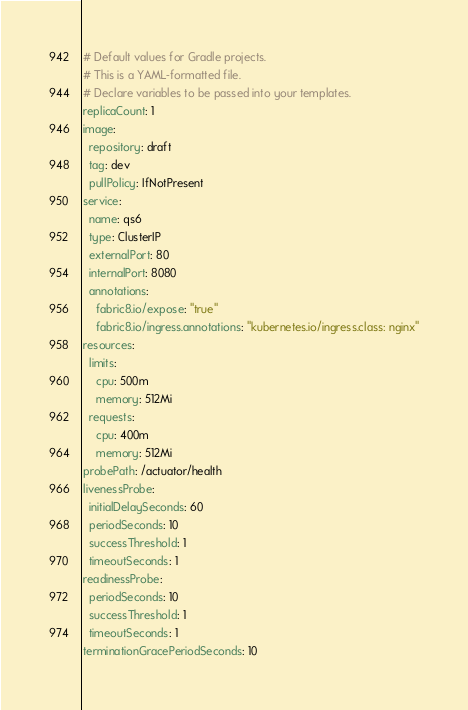<code> <loc_0><loc_0><loc_500><loc_500><_YAML_># Default values for Gradle projects.
# This is a YAML-formatted file.
# Declare variables to be passed into your templates.
replicaCount: 1
image:
  repository: draft
  tag: dev
  pullPolicy: IfNotPresent
service:
  name: qs6
  type: ClusterIP
  externalPort: 80
  internalPort: 8080
  annotations:
    fabric8.io/expose: "true"
    fabric8.io/ingress.annotations: "kubernetes.io/ingress.class: nginx"
resources:
  limits:
    cpu: 500m
    memory: 512Mi
  requests:
    cpu: 400m
    memory: 512Mi
probePath: /actuator/health
livenessProbe:
  initialDelaySeconds: 60
  periodSeconds: 10
  successThreshold: 1
  timeoutSeconds: 1
readinessProbe:
  periodSeconds: 10
  successThreshold: 1
  timeoutSeconds: 1
terminationGracePeriodSeconds: 10
</code> 